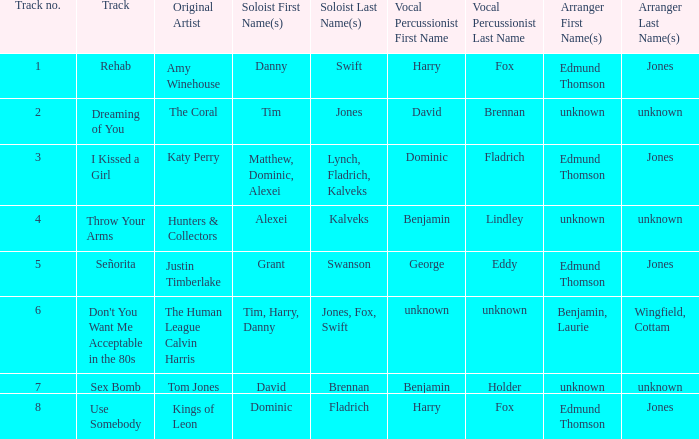Who is the original artist of "Use Somebody"? Kings of Leon. 